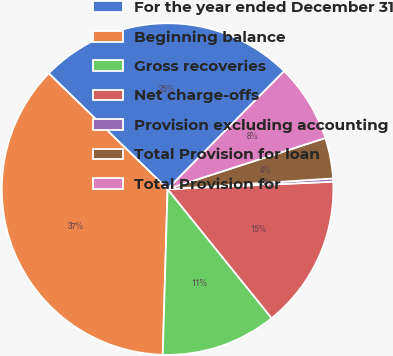Convert chart to OTSL. <chart><loc_0><loc_0><loc_500><loc_500><pie_chart><fcel>For the year ended December 31<fcel>Beginning balance<fcel>Gross recoveries<fcel>Net charge-offs<fcel>Provision excluding accounting<fcel>Total Provision for loan<fcel>Total Provision for<nl><fcel>25.12%<fcel>36.82%<fcel>11.26%<fcel>14.91%<fcel>0.31%<fcel>3.96%<fcel>7.61%<nl></chart> 